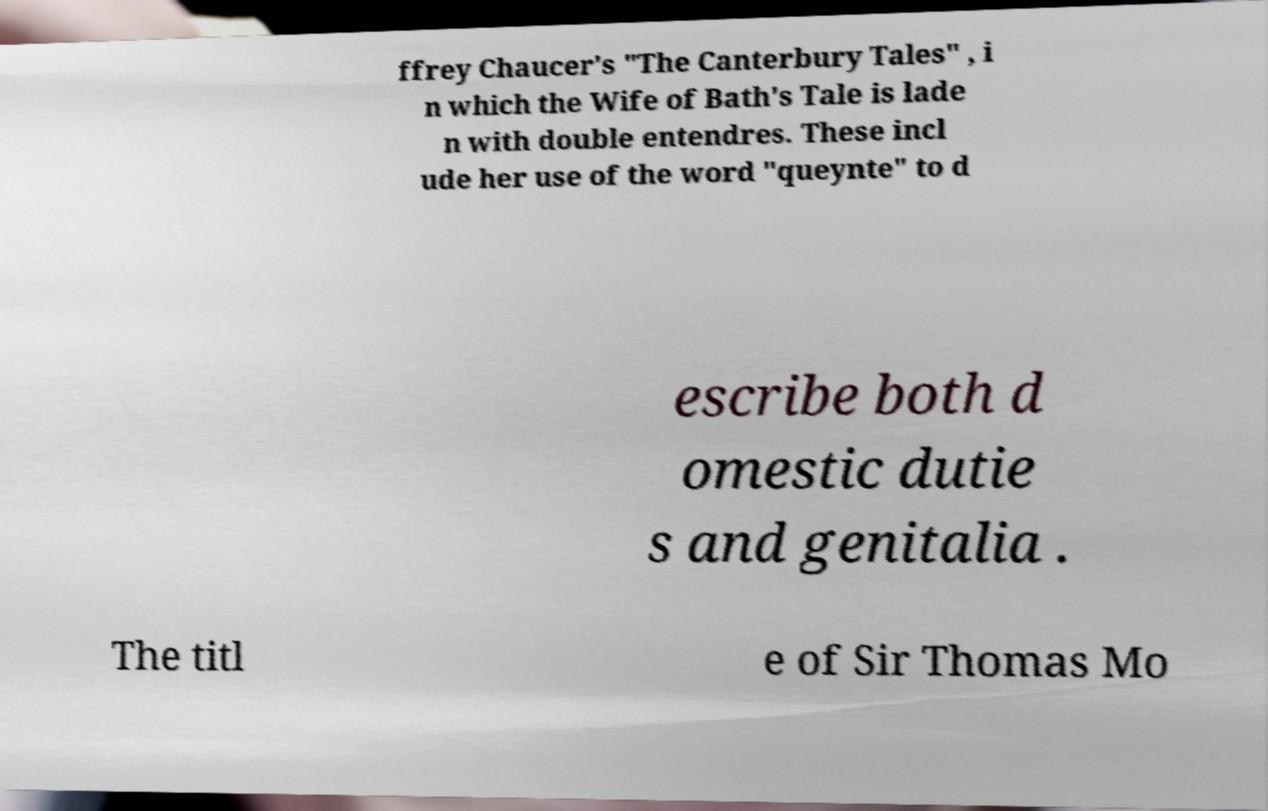Please identify and transcribe the text found in this image. ffrey Chaucer's "The Canterbury Tales" , i n which the Wife of Bath's Tale is lade n with double entendres. These incl ude her use of the word "queynte" to d escribe both d omestic dutie s and genitalia . The titl e of Sir Thomas Mo 